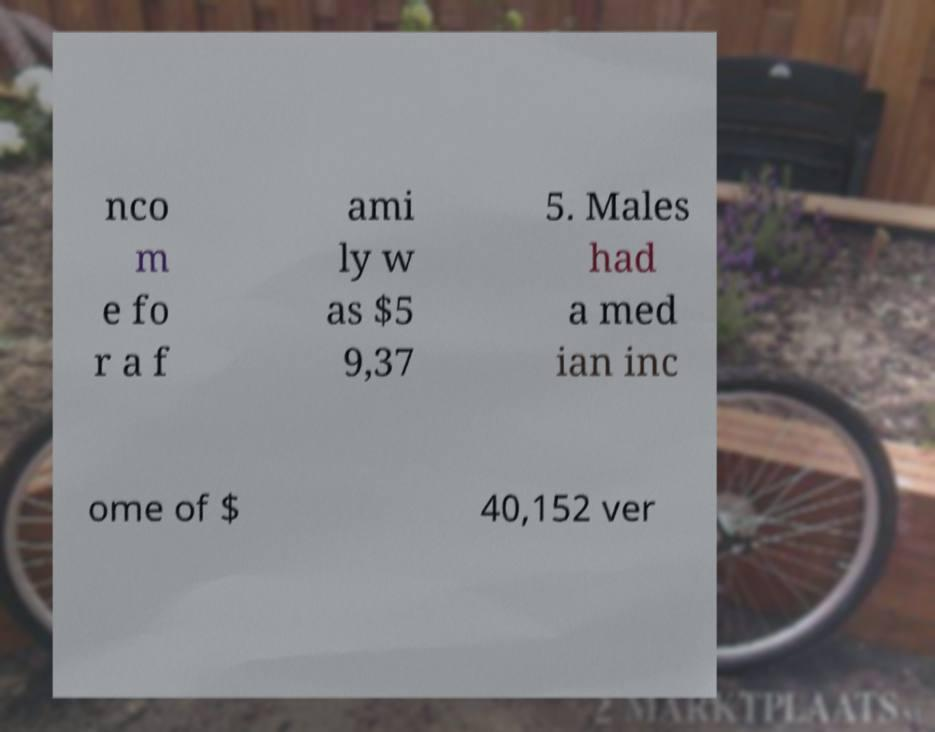For documentation purposes, I need the text within this image transcribed. Could you provide that? nco m e fo r a f ami ly w as $5 9,37 5. Males had a med ian inc ome of $ 40,152 ver 